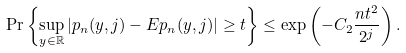<formula> <loc_0><loc_0><loc_500><loc_500>\Pr \left \{ \sup _ { y \in \mathbb { R } } | p _ { n } ( y , j ) - E p _ { n } ( y , j ) | \geq t \right \} \leq \exp \left ( - C _ { 2 } \frac { n t ^ { 2 } } { 2 ^ { j } } \right ) .</formula> 